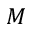Convert formula to latex. <formula><loc_0><loc_0><loc_500><loc_500>M</formula> 